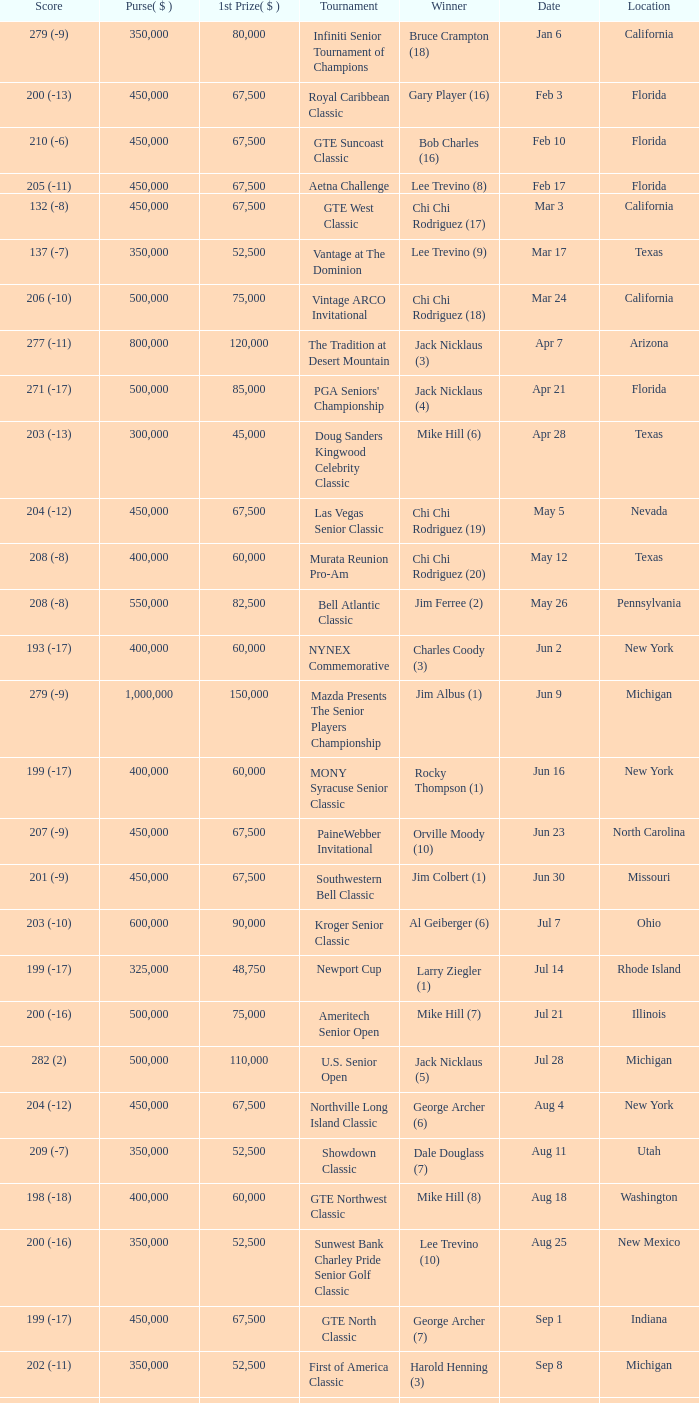What is the purse for the tournament with a winning score of 212 (-4), and a 1st prize of under $105,000? None. 